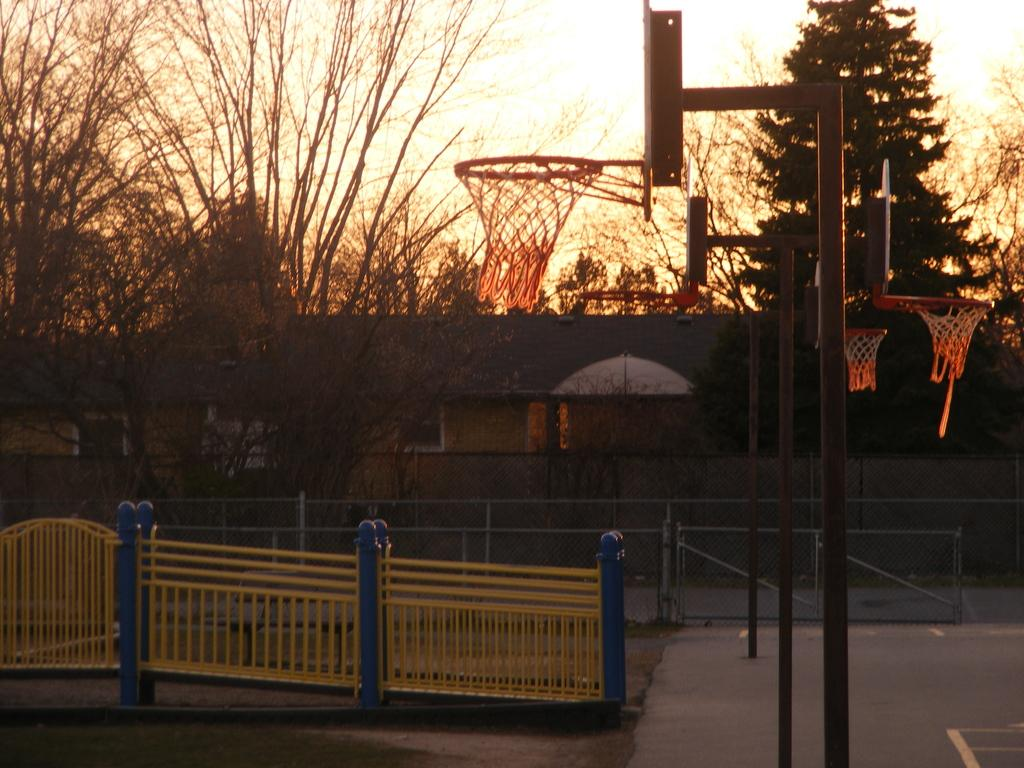What can be seen in the sky in the image? The sky is visible in the image. What type of natural elements are present in the image? There are trees in the image. What type of man-made structures can be seen in the image? There are buildings, poles, and basketball nets in the image. What type of protective barriers are present in the image? There are iron grills in the image. What type of surface is visible in the image? The ground is visible in the image, and there is also a floor in the image. Can you see a hill in the image? There is no hill present in the image. How many hands are visible in the image? There are no hands visible in the image. 